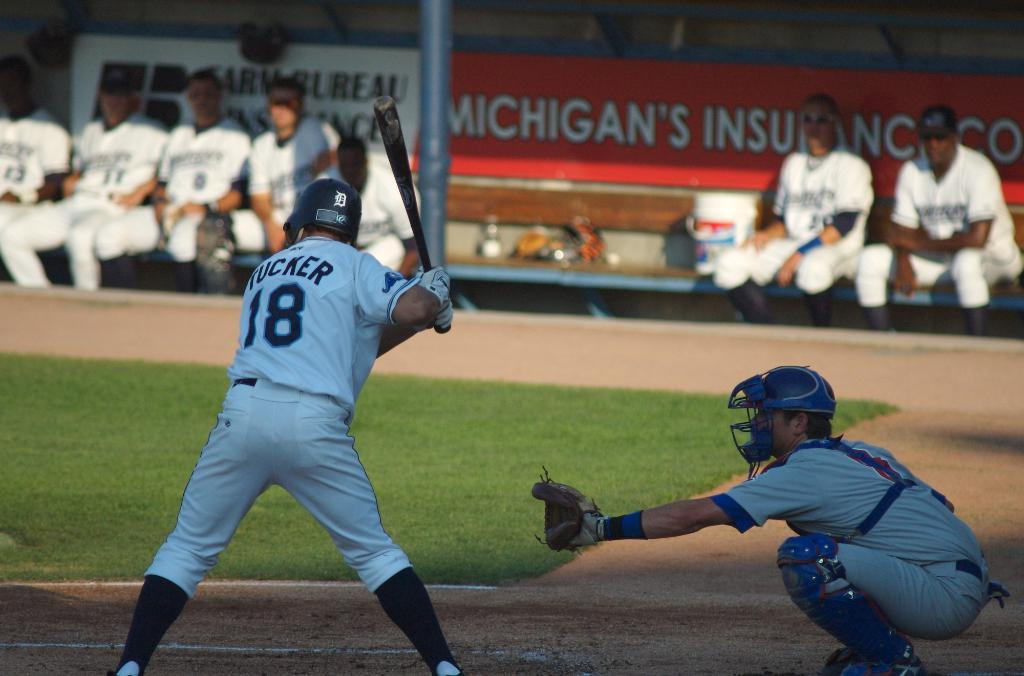<image>
Summarize the visual content of the image. Tucker #18 baseball batter that is getting ready to hit the ball. 